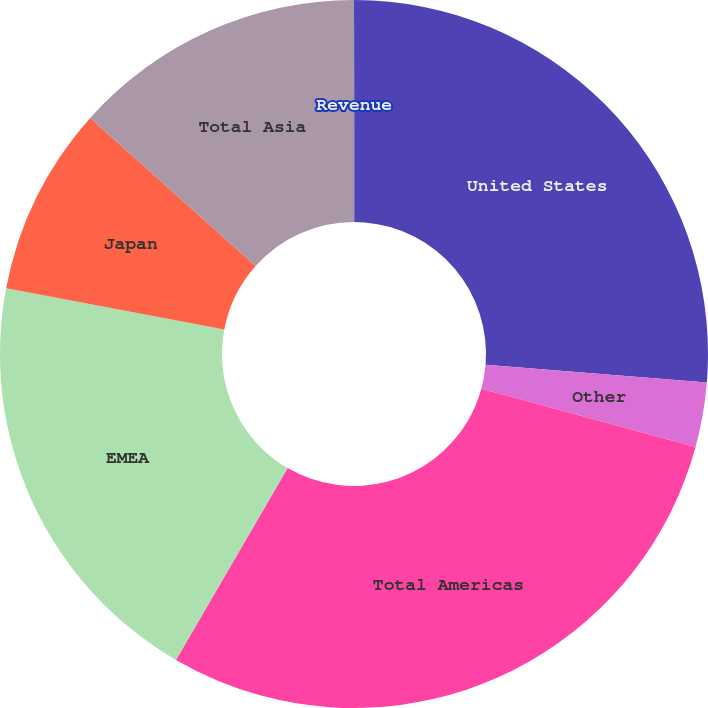Convert chart to OTSL. <chart><loc_0><loc_0><loc_500><loc_500><pie_chart><fcel>Revenue<fcel>United States<fcel>Other<fcel>Total Americas<fcel>EMEA<fcel>Japan<fcel>Total Asia<nl><fcel>0.04%<fcel>26.24%<fcel>2.95%<fcel>29.15%<fcel>19.58%<fcel>8.65%<fcel>13.38%<nl></chart> 